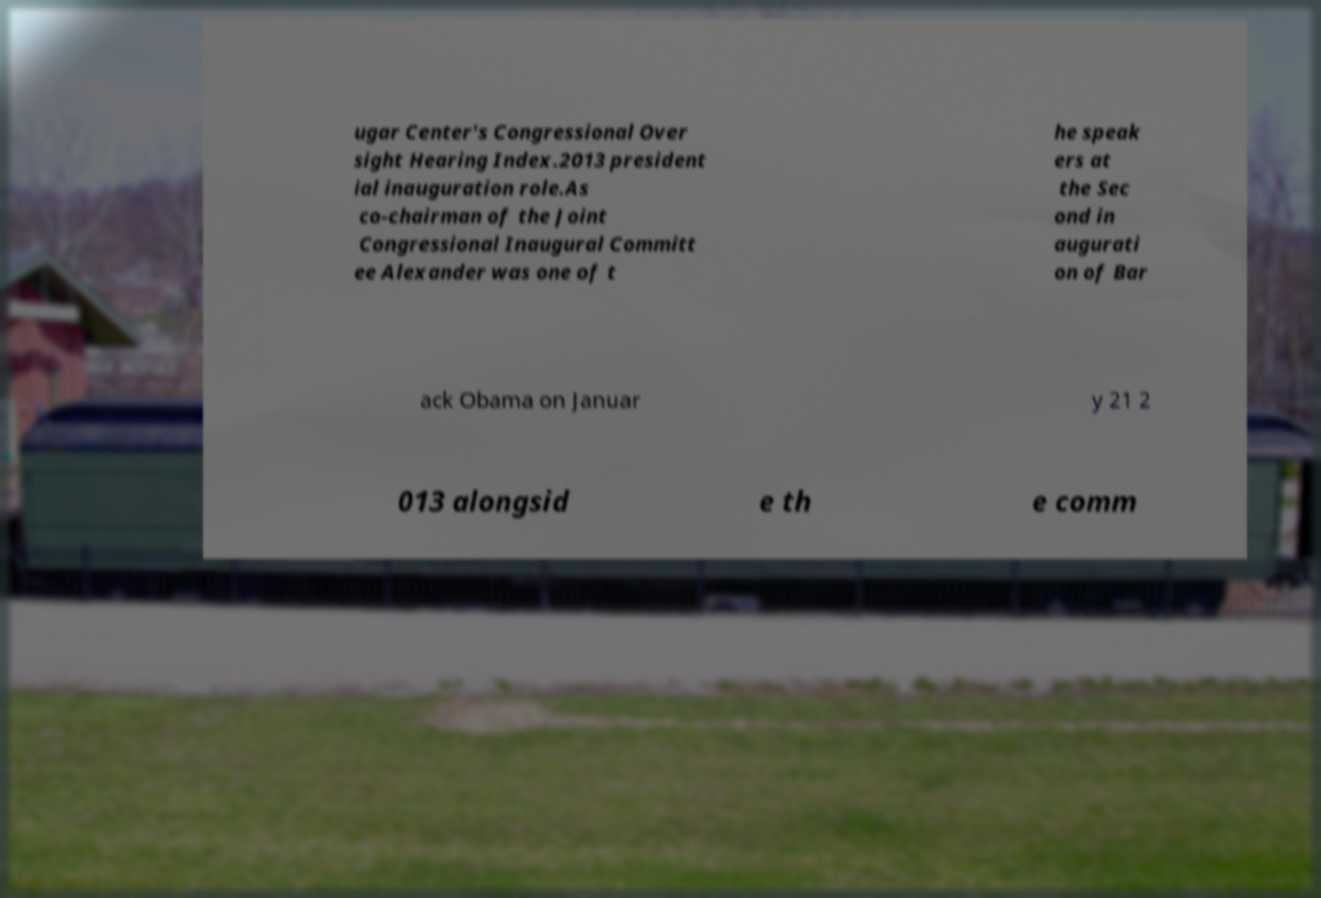For documentation purposes, I need the text within this image transcribed. Could you provide that? ugar Center's Congressional Over sight Hearing Index.2013 president ial inauguration role.As co-chairman of the Joint Congressional Inaugural Committ ee Alexander was one of t he speak ers at the Sec ond in augurati on of Bar ack Obama on Januar y 21 2 013 alongsid e th e comm 